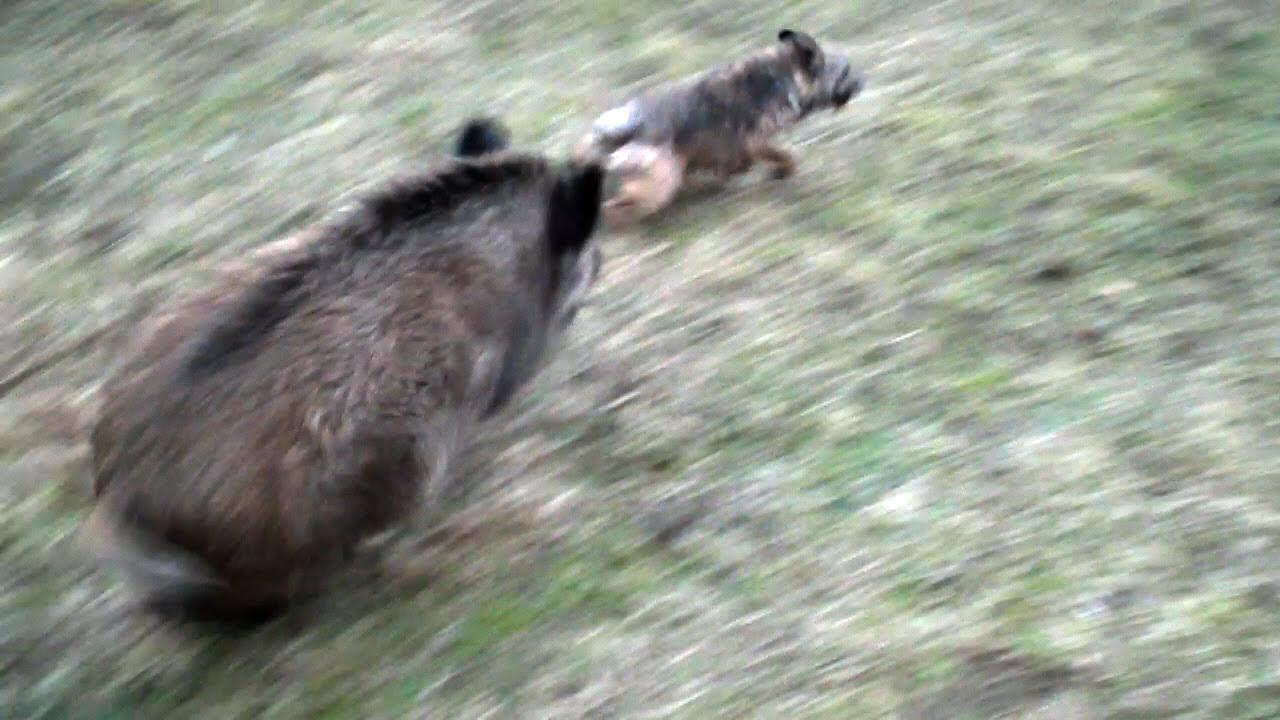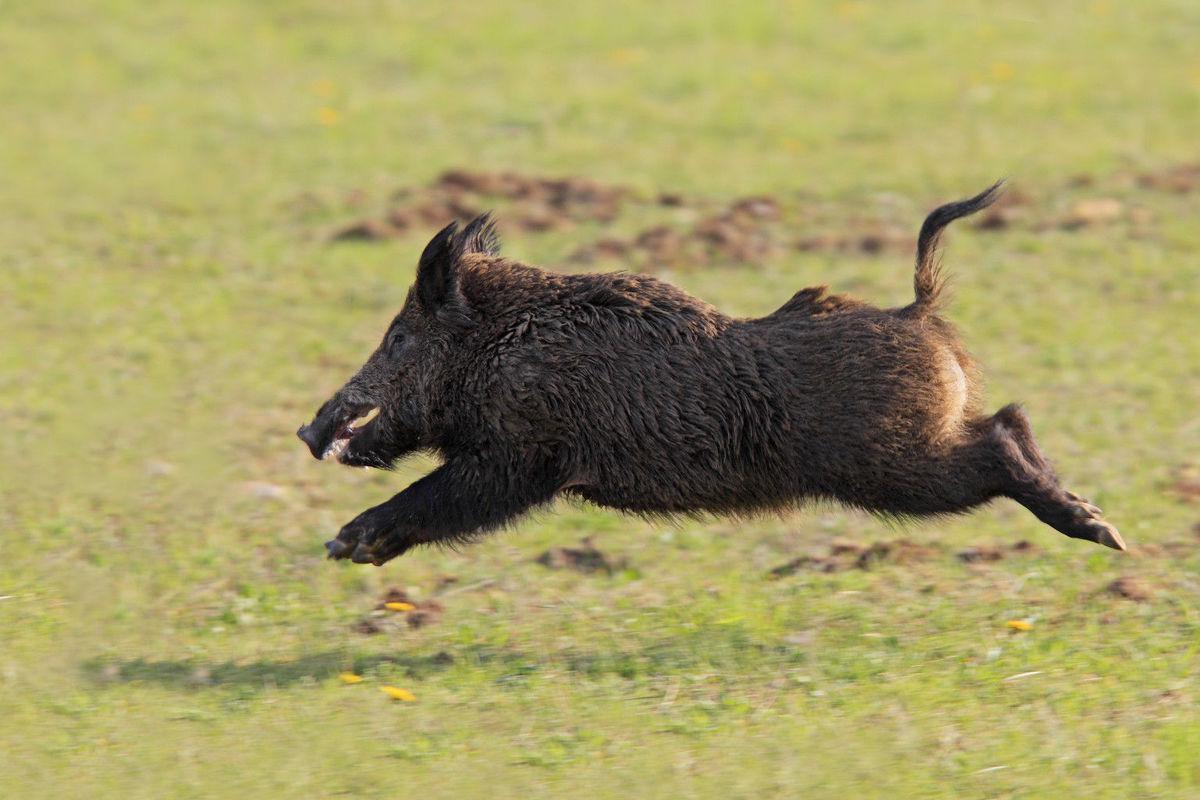The first image is the image on the left, the second image is the image on the right. Analyze the images presented: Is the assertion "At least one wild boar is running toward the right, and another wild boar is running toward the left." valid? Answer yes or no. Yes. The first image is the image on the left, the second image is the image on the right. Given the left and right images, does the statement "One image shows an actual wild pig bounding across the ground in profile, and each image includes an animal figure in a motion pose." hold true? Answer yes or no. Yes. 